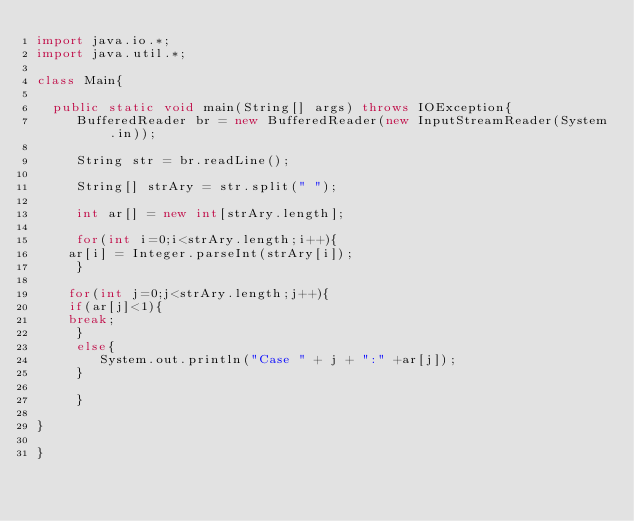<code> <loc_0><loc_0><loc_500><loc_500><_Java_>import java.io.*;
import java.util.*;

class Main{

  public static void main(String[] args) throws IOException{
     BufferedReader br = new BufferedReader(new InputStreamReader(System.in));

     String str = br.readLine();

     String[] strAry = str.split(" ");

     int ar[] = new int[strAry.length];

     for(int i=0;i<strAry.length;i++){
	ar[i] = Integer.parseInt(strAry[i]);
     }

    for(int j=0;j<strAry.length;j++){
    if(ar[j]<1){
	break;
     }
     else{
        System.out.println("Case " + j + ":" +ar[j]);
     }

     }

}

}</code> 